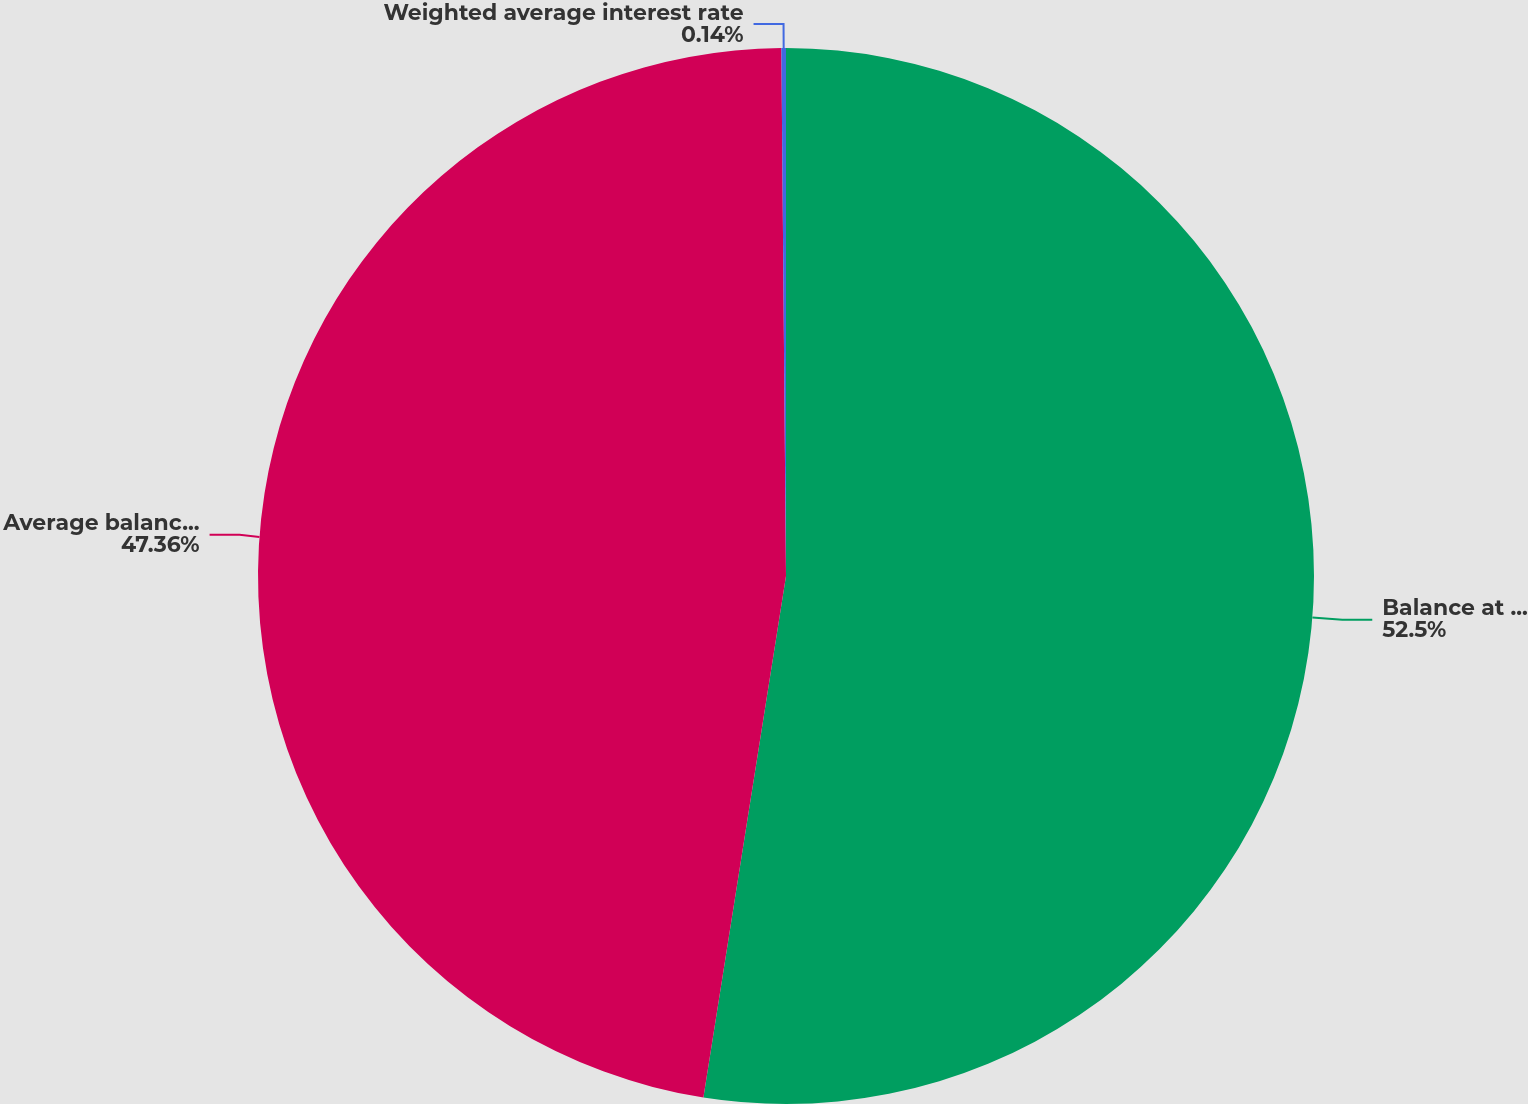Convert chart to OTSL. <chart><loc_0><loc_0><loc_500><loc_500><pie_chart><fcel>Balance at period-end<fcel>Average balance(2)<fcel>Weighted average interest rate<nl><fcel>52.5%<fcel>47.36%<fcel>0.14%<nl></chart> 